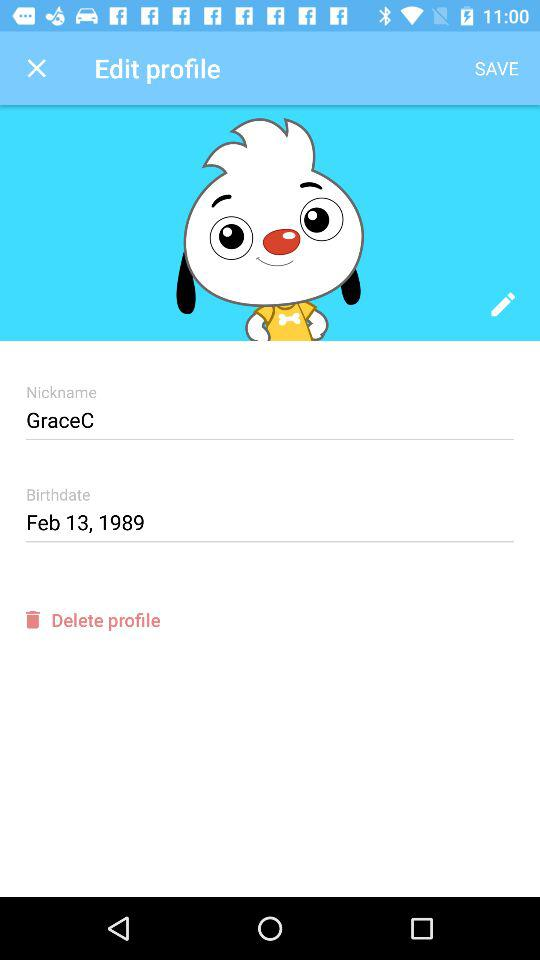What is the nickname? The nickname is "GraceC". 